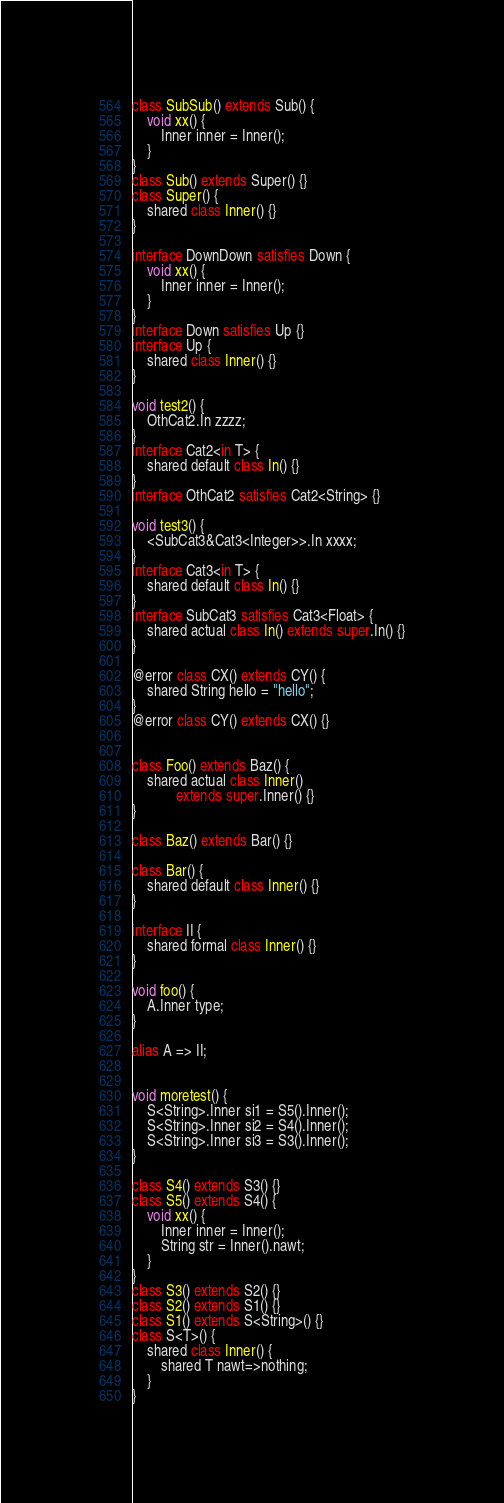<code> <loc_0><loc_0><loc_500><loc_500><_Ceylon_>
class SubSub() extends Sub() {
    void xx() {
        Inner inner = Inner();
    }
}
class Sub() extends Super() {}
class Super() {
    shared class Inner() {}
}

interface DownDown satisfies Down {
    void xx() {
        Inner inner = Inner();
    }
}
interface Down satisfies Up {}
interface Up {
    shared class Inner() {}
}

void test2() {
    OthCat2.In zzzz;
}
interface Cat2<in T> {
    shared default class In() {}
}
interface OthCat2 satisfies Cat2<String> {}

void test3() {
    <SubCat3&Cat3<Integer>>.In xxxx;
}
interface Cat3<in T> {
    shared default class In() {}
}
interface SubCat3 satisfies Cat3<Float> {
    shared actual class In() extends super.In() {}
}

@error class CX() extends CY() {
    shared String hello = "hello";
}
@error class CY() extends CX() {}


class Foo() extends Baz() {
    shared actual class Inner()
            extends super.Inner() {}
}

class Baz() extends Bar() {}

class Bar() {
    shared default class Inner() {}
}

interface II {
    shared formal class Inner() {}
}

void foo() {
    A.Inner type;
}

alias A => II;


void moretest() {
    S<String>.Inner si1 = S5().Inner();
    S<String>.Inner si2 = S4().Inner();
    S<String>.Inner si3 = S3().Inner();
}

class S4() extends S3() {}
class S5() extends S4() {
    void xx() {
        Inner inner = Inner();
        String str = Inner().nawt;
    }
}
class S3() extends S2() {}
class S2() extends S1() {}
class S1() extends S<String>() {}
class S<T>() {
    shared class Inner() {
        shared T nawt=>nothing;
    }
}
</code> 